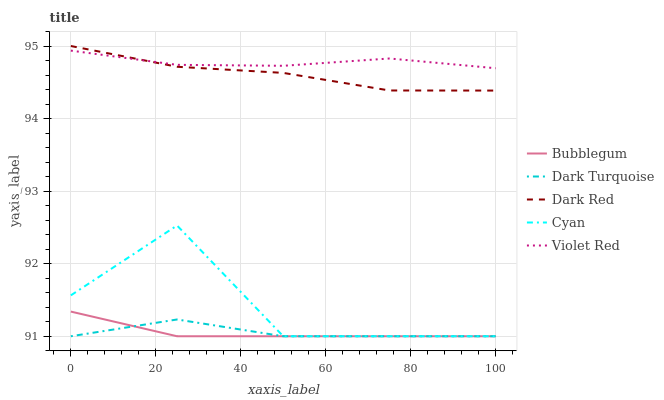Does Cyan have the minimum area under the curve?
Answer yes or no. No. Does Cyan have the maximum area under the curve?
Answer yes or no. No. Is Violet Red the smoothest?
Answer yes or no. No. Is Violet Red the roughest?
Answer yes or no. No. Does Violet Red have the lowest value?
Answer yes or no. No. Does Cyan have the highest value?
Answer yes or no. No. Is Dark Turquoise less than Dark Red?
Answer yes or no. Yes. Is Violet Red greater than Cyan?
Answer yes or no. Yes. Does Dark Turquoise intersect Dark Red?
Answer yes or no. No. 